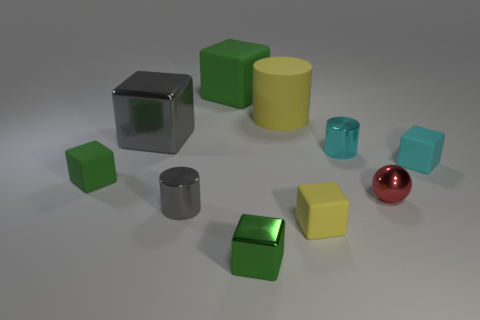How many green cubes must be subtracted to get 1 green cubes? 2 Subtract all yellow cylinders. How many green cubes are left? 3 Subtract all cyan blocks. How many blocks are left? 5 Subtract all large matte cubes. How many cubes are left? 5 Subtract all blue cubes. Subtract all purple cylinders. How many cubes are left? 6 Subtract all cylinders. How many objects are left? 7 Subtract all big purple metal things. Subtract all yellow rubber blocks. How many objects are left? 9 Add 3 tiny gray metallic objects. How many tiny gray metallic objects are left? 4 Add 6 small red objects. How many small red objects exist? 7 Subtract 0 brown blocks. How many objects are left? 10 